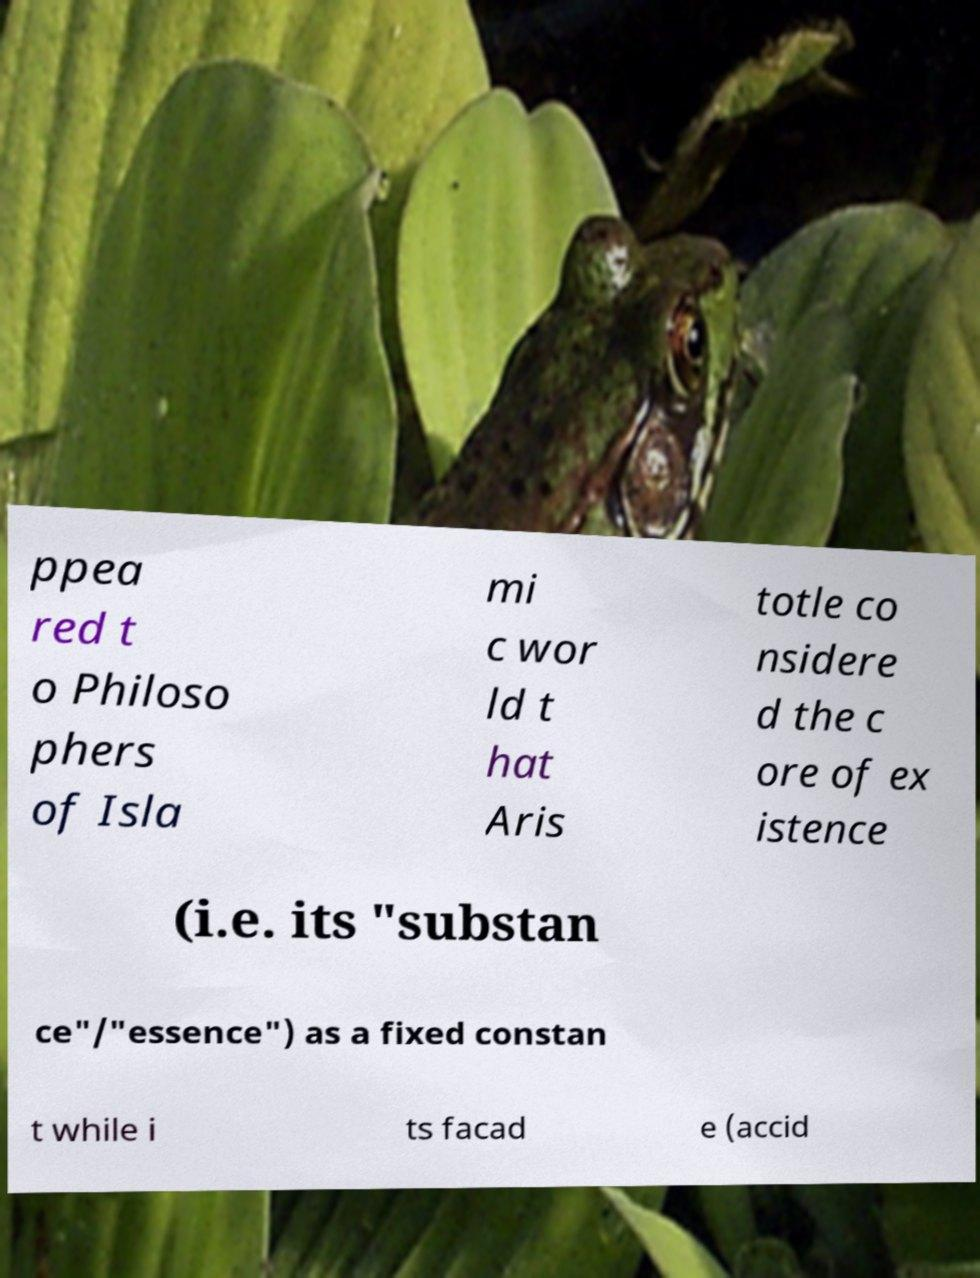I need the written content from this picture converted into text. Can you do that? ppea red t o Philoso phers of Isla mi c wor ld t hat Aris totle co nsidere d the c ore of ex istence (i.e. its "substan ce"/"essence") as a fixed constan t while i ts facad e (accid 